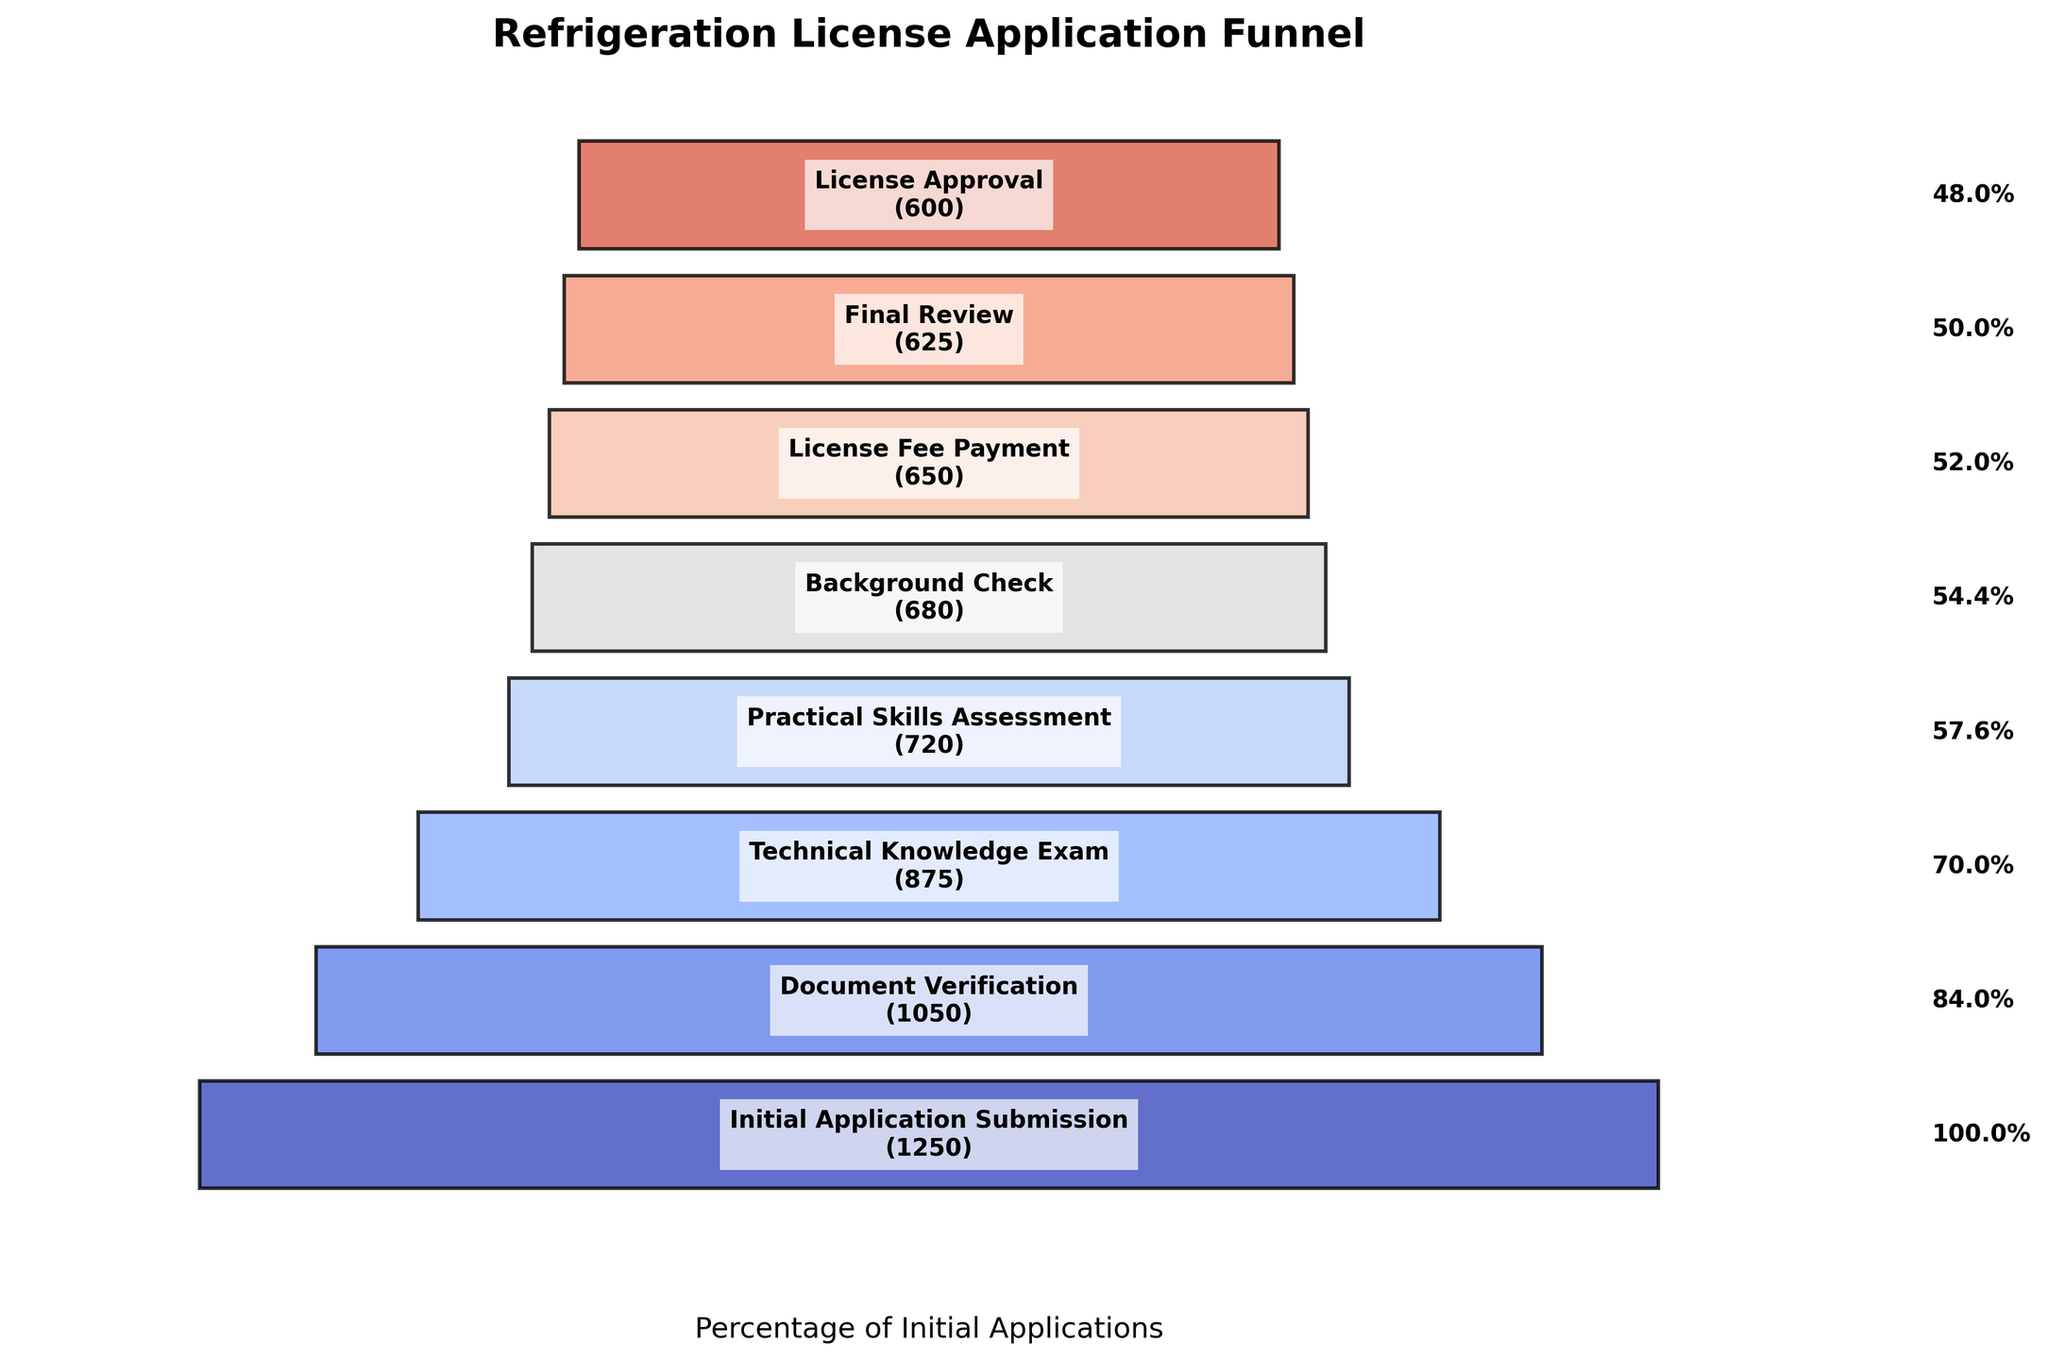Which stage has the most applications? Look at the first bar labeled "Initial Application Submission" at the top of the funnel chart, which shows 1250 applications.
Answer: Initial Application Submission What percentage of initial applications are approved for a license? The funnel chart shows 600 applications at the "License Approval" stage from an initial 1250 applications. Calculate (600 / 1250) * 100 to get the percentage.
Answer: 48% How many applications did not pass the Practical Skills Assessment? Subtract the applications passing the "Practical Skills Assessment" (720) from the applications that took the "Technical Knowledge Exam" (875). Thus, 875 - 720 = 155 applications.
Answer: 155 Which stage sees the highest drop in applications compared to the previous stage? Compare the differences in applications between each consecutive stage. The biggest drop is from "Technical Knowledge Exam" (875) to "Practical Skills Assessment" (720), a difference of 155 applications.
Answer: Technical Knowledge Exam to Practical Skills Assessment Calculate the total number of applications from initial submission to final approval. Sum the applications at each stage: 1250 (Initial Application Submission) + 1050 (Document Verification) + 875 (Technical Knowledge Exam) + 720 (Practical Skills Assessment) + 680 (Background Check) + 650 (License Fee Payment) + 625 (Final Review) + 600 (License Approval) = 7450 applications.
Answer: 7450 applications What proportion of applications pass the Background Check relative to those that take the Practical Skills Assessment? Divide the applications that pass the Background Check (680) by those that take the Practical Skills Assessment (720): 680 / 720. Convert to a percentage by multiplying by 100.
Answer: 94.4% At which stage do we first see less than 90% of the initial applications? Calculate 90% of the initial applications (1250), which is 1250 * 0.90 = 1125. The first stage falling below 1125 is the "Document Verification" stage with 1050 applications.
Answer: Document Verification What is the difference in the number of applications between Document Verification and Final Review stages? Subtract the number of applications at the "Final Review" stage (625) from those at the "Document Verification" stage (1050): 1050 - 625 = 425.
Answer: 425 applications 